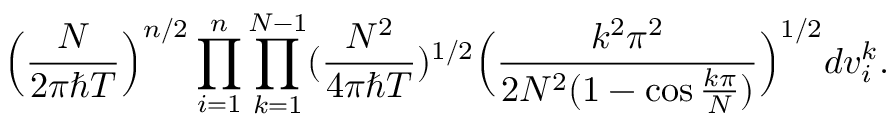Convert formula to latex. <formula><loc_0><loc_0><loc_500><loc_500>\left ( \frac { N } { 2 \pi \hbar { T } } \right ) ^ { n / 2 } \prod _ { i = 1 } ^ { n } \prod _ { k = 1 } ^ { N - 1 } ( \frac { N ^ { 2 } } { 4 \pi \hbar { T } } ) ^ { 1 / 2 } \left ( \frac { k ^ { 2 } \pi ^ { 2 } } { 2 N ^ { 2 } ( 1 - \cos \frac { k \pi } { N } ) } \right ) ^ { 1 / 2 } d v _ { i } ^ { k } .</formula> 